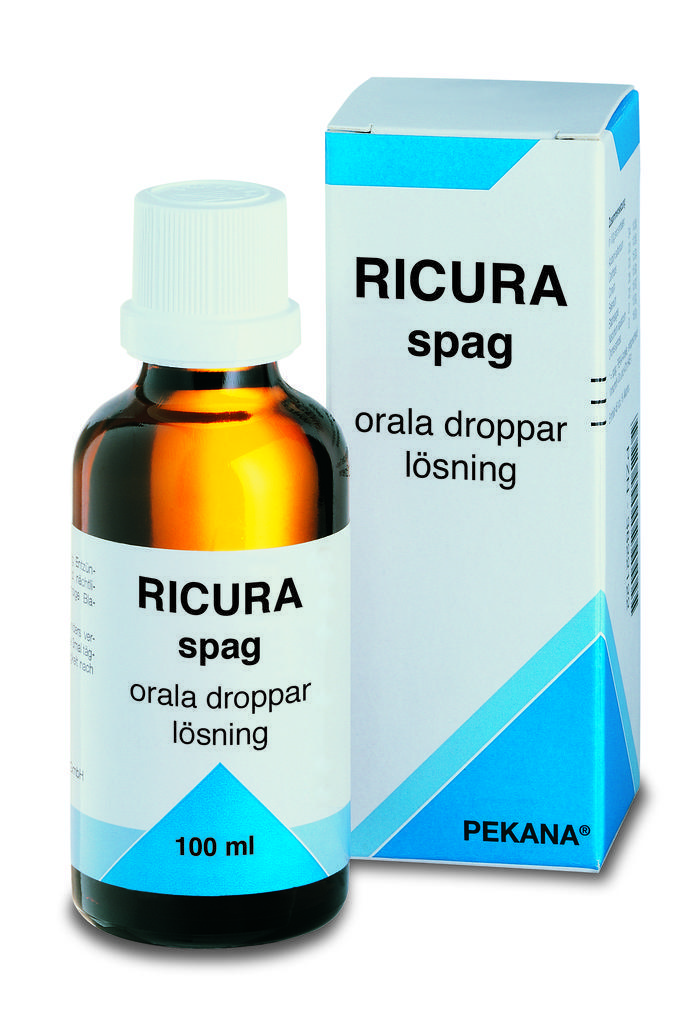In one or two sentences, can you explain what this image depicts? It is the image of a tonic and the background of the tonic is in white color. 